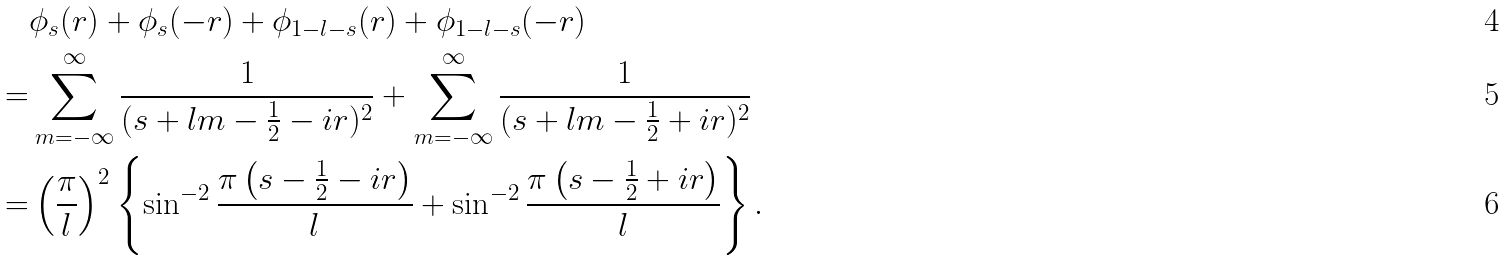<formula> <loc_0><loc_0><loc_500><loc_500>& \phi _ { s } ( r ) + \phi _ { s } ( - r ) + \phi _ { 1 - l - s } ( r ) + \phi _ { 1 - l - s } ( - r ) \\ = & \sum _ { m = - \infty } ^ { \infty } \frac { 1 } { ( s + l m - \frac { 1 } { 2 } - i r ) ^ { 2 } } + \sum _ { m = - \infty } ^ { \infty } \frac { 1 } { ( s + l m - \frac { 1 } { 2 } + i r ) ^ { 2 } } \\ = & \left ( \frac { \pi } { l } \right ) ^ { 2 } \left \{ \sin ^ { - 2 } \frac { \pi \left ( s - \frac { 1 } { 2 } - i r \right ) } { l } + \sin ^ { - 2 } \frac { \pi \left ( s - \frac { 1 } { 2 } + i r \right ) } { l } \right \} .</formula> 